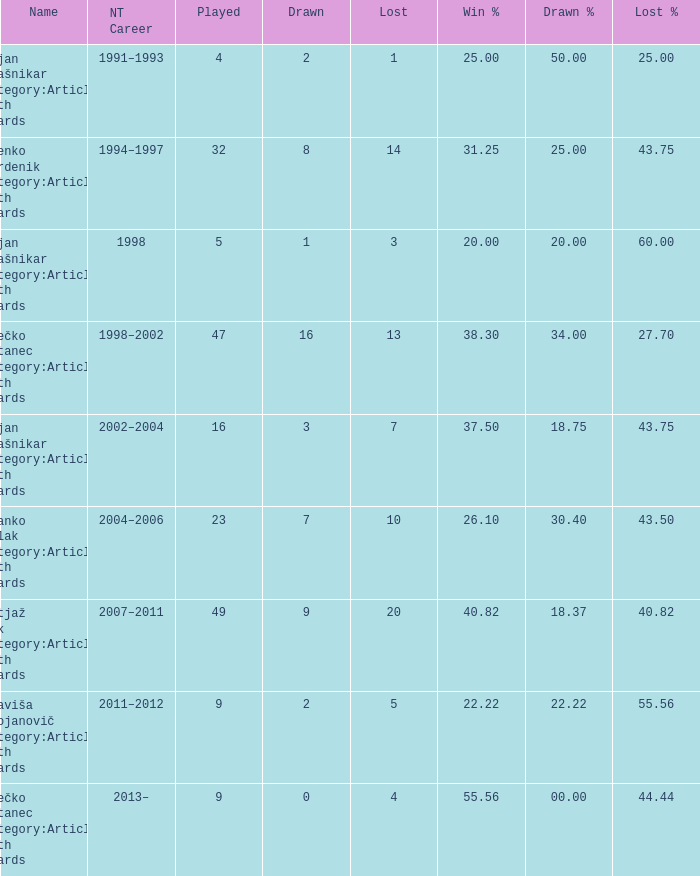How many values for Lost% occur when the value for drawn is 8 and less than 14 lost? 0.0. 